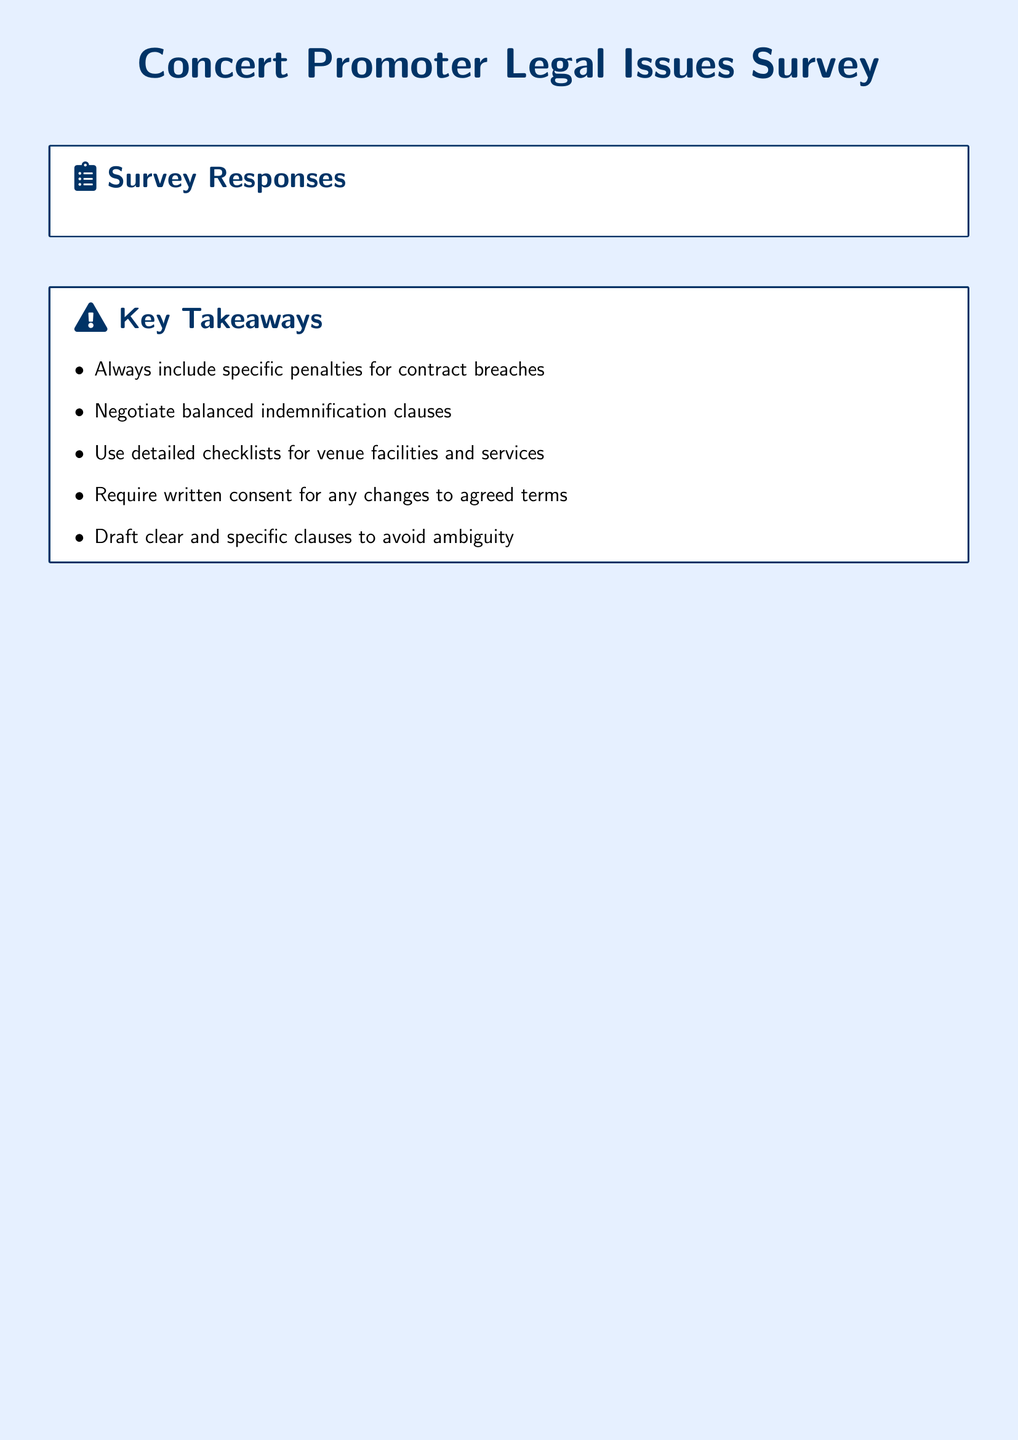What is the name of the manager at Live Nation? The document lists Ella Thompson as the manager at Live Nation.
Answer: Ella Thompson What issue is related to last-minute cancellations? Ella Thompson mentioned breaches of contract due to last-minute cancellations by venues.
Answer: Last-minute cancellations Which company does James Murray represent? The document states that James Murray is the Director at AEG Presents.
Answer: AEG Presents What resolution does Olivia Chen suggest for unauthorized venue switches? She advises requiring written consent for any changes to agreed terms.
Answer: Require written consent What common issue is faced by Lucas Werner? He reported venue overbooking as a breach of contract issue.
Answer: Venue overbooking What is one key takeaway from the survey responses? One takeaway emphasizes the importance of including specific penalties for contract breaches.
Answer: Specific penalties for contract breaches What type of clauses do several respondents find problematic? Indemnification clauses are mentioned as overly broad or unfairly pushing liability.
Answer: Indemnification clauses Which promoter mentioned detailed checklists as a resolution? James Murray suggested using detailed checklists for venue facilities and services.
Answer: James Murray 